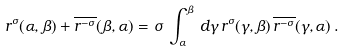Convert formula to latex. <formula><loc_0><loc_0><loc_500><loc_500>r ^ { \sigma } ( \alpha , \beta ) + \overline { r ^ { - \sigma } } ( \beta , \alpha ) = \sigma \, \int _ { \alpha } ^ { \beta } \, d \gamma \, r ^ { \sigma } ( \gamma , \beta ) \, \overline { r ^ { - \sigma } } ( \gamma , \alpha ) \, .</formula> 